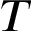<formula> <loc_0><loc_0><loc_500><loc_500>T</formula> 